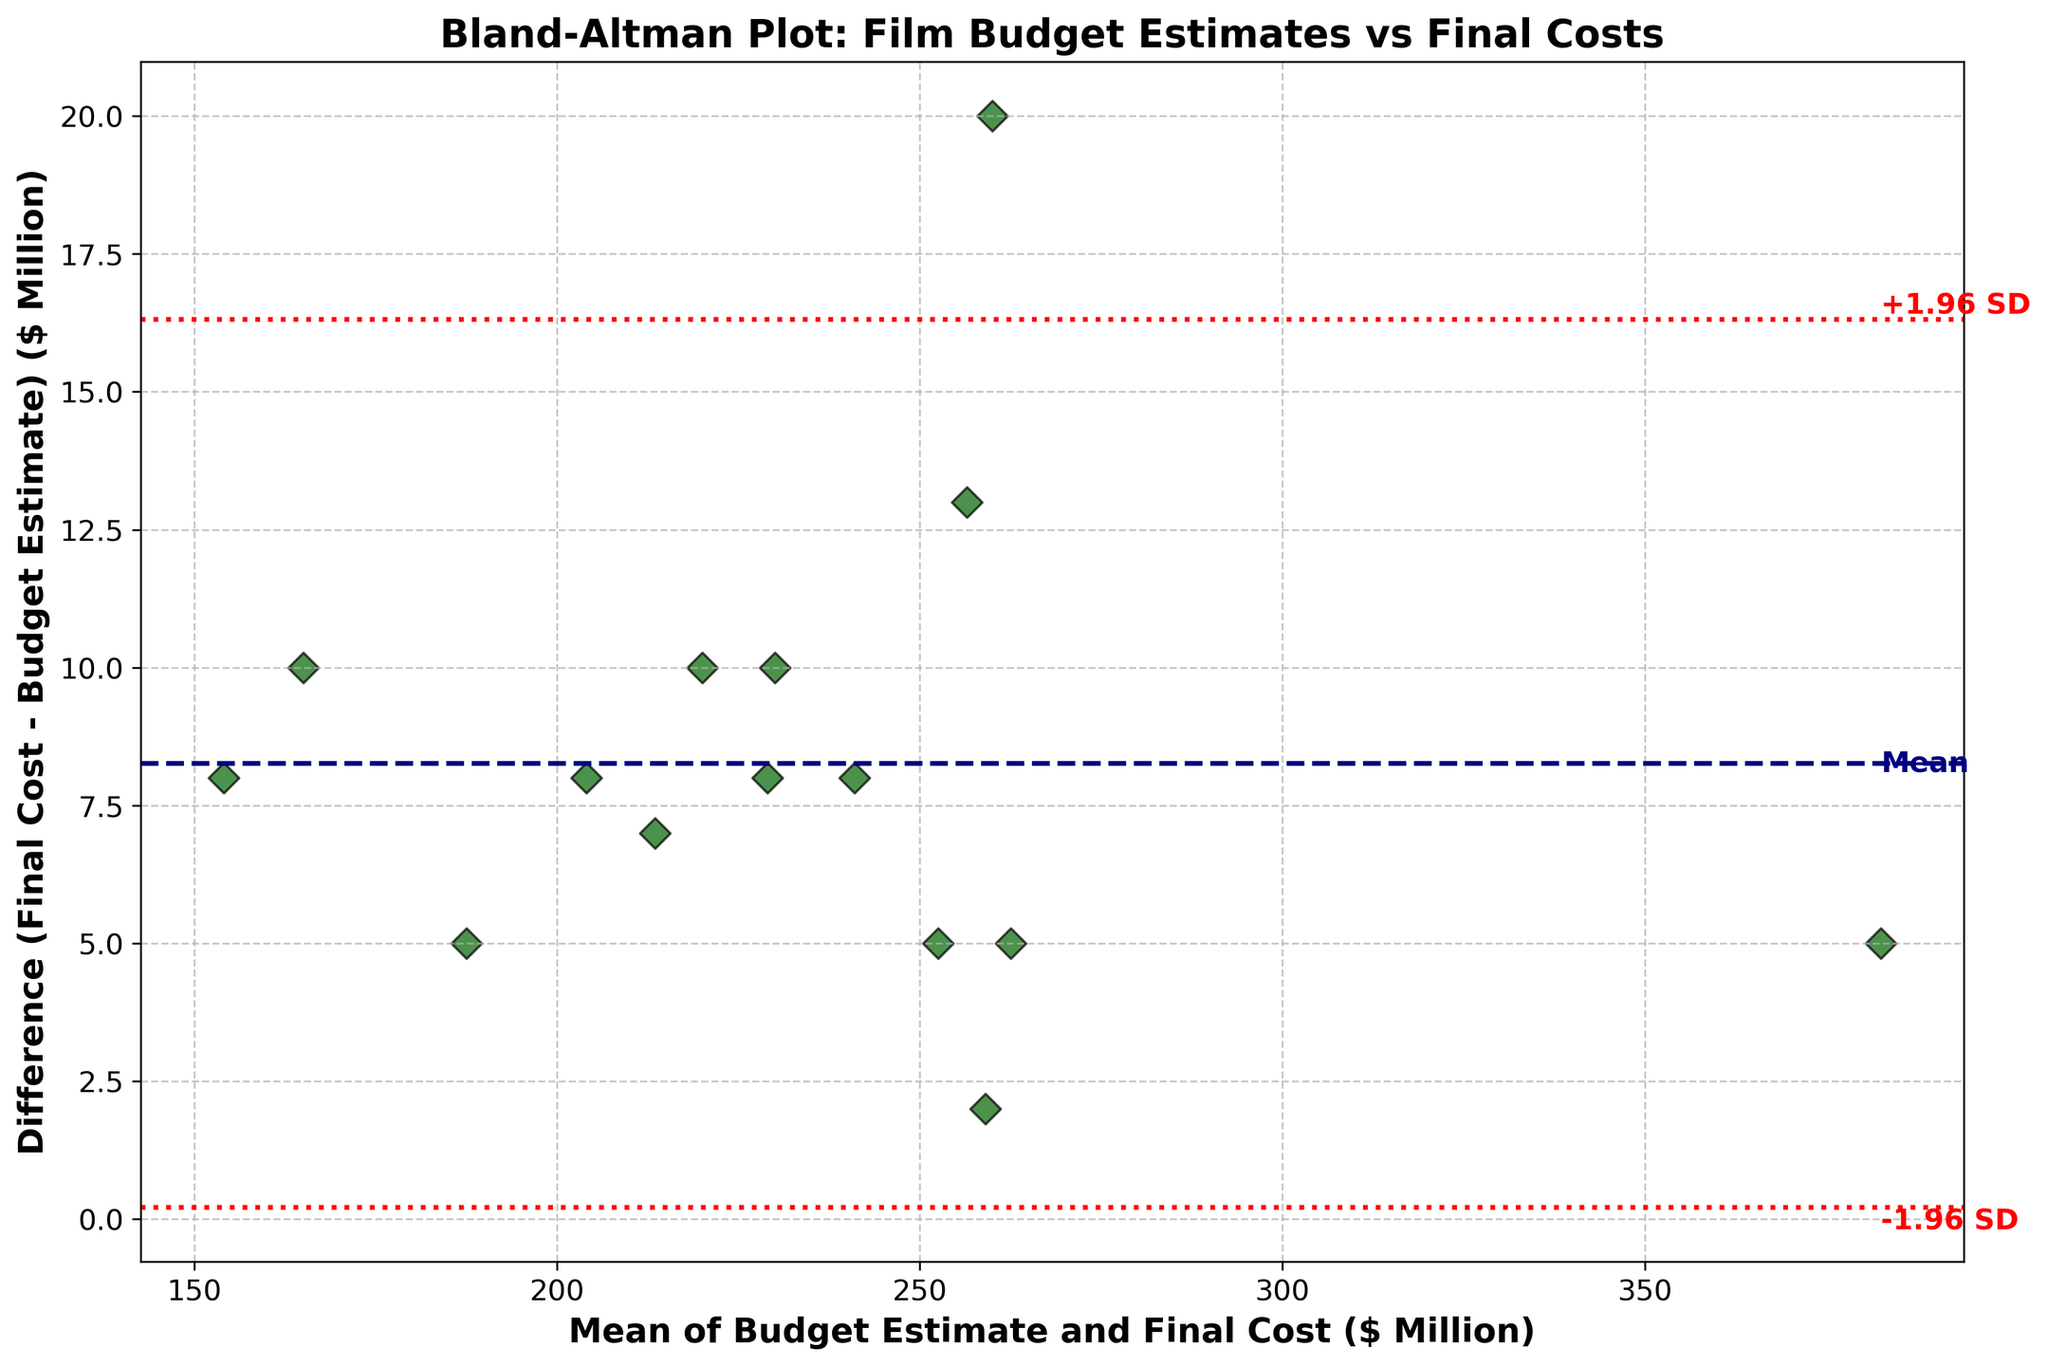What is the title of the figure? The title is typically displayed at the top of the plot. For this figure, it clearly shows "Bland-Altman Plot: Film Budget Estimates vs Final Costs."
Answer: Bland-Altman Plot: Film Budget Estimates vs Final Costs What is shown on the x-axis? The x-axis label is usually found at the bottom of the plot. Here, it mentions "Mean of Budget Estimate and Final Cost ($ Million)."
Answer: Mean of Budget Estimate and Final Cost ($ Million) How many data points does the figure contain? The scatter points in the plot represent the data points. Counting these gives you the total number of data points. In this figure, you can count 15 scatter points.
Answer: 15 What do the red dashed lines represent in the plot? The red dashed lines are typically used to indicate limits of agreement. In this plot, they show the upper and lower limits of agreement (+1.96 SD and -1.96 SD).
Answer: Limits of agreement (+1.96 SD and -1.96 SD) What is the average difference between final costs and budget estimates? The average difference is shown as the horizontal navy line, which is labeled as "Mean." Upon visual inspection, this line is at approximately 6 million dollars.
Answer: 6 million dollars Which movie had the largest difference between budget estimate and final cost? By examining the scatter points for their vertical position and matching the point to the film title, it appears "Avengers: Age of Ultron" (difference of 20 million) shows the largest difference.
Answer: Avengers: Age of Ultron What are the upper and lower limits of agreement? The limits are defined as the mean difference plus or minus 1.96 times the standard deviation of the differences. The red dashed lines provide these values, which we can see are approximately +20 million and -8 million dollars.
Answer: +20 million and -8 million dollars Which data points lie outside the limits of agreement? Data points outside the red dashed lines, upper and lower limits of agreement, are checked. In this plot, "Avengers: Age of Ultron" is above the upper limit and "John Carter" is above it as well. No points lie below the lower limit.
Answer: Avengers: Age of Ultron, John Carter What is the range of the x-axis values? The range can be determined by looking at the endpoints of the axis. For this plot, it ranges from approximately 150 to 390 million dollars.
Answer: 150 to 390 million dollars Is there a trend visible between the difference and the mean values? Observing the scatter points, we look for any discernible pattern or trend. There seems to be no systematic relationship, suggesting no clear trend between differences and mean values.
Answer: No clear trend 